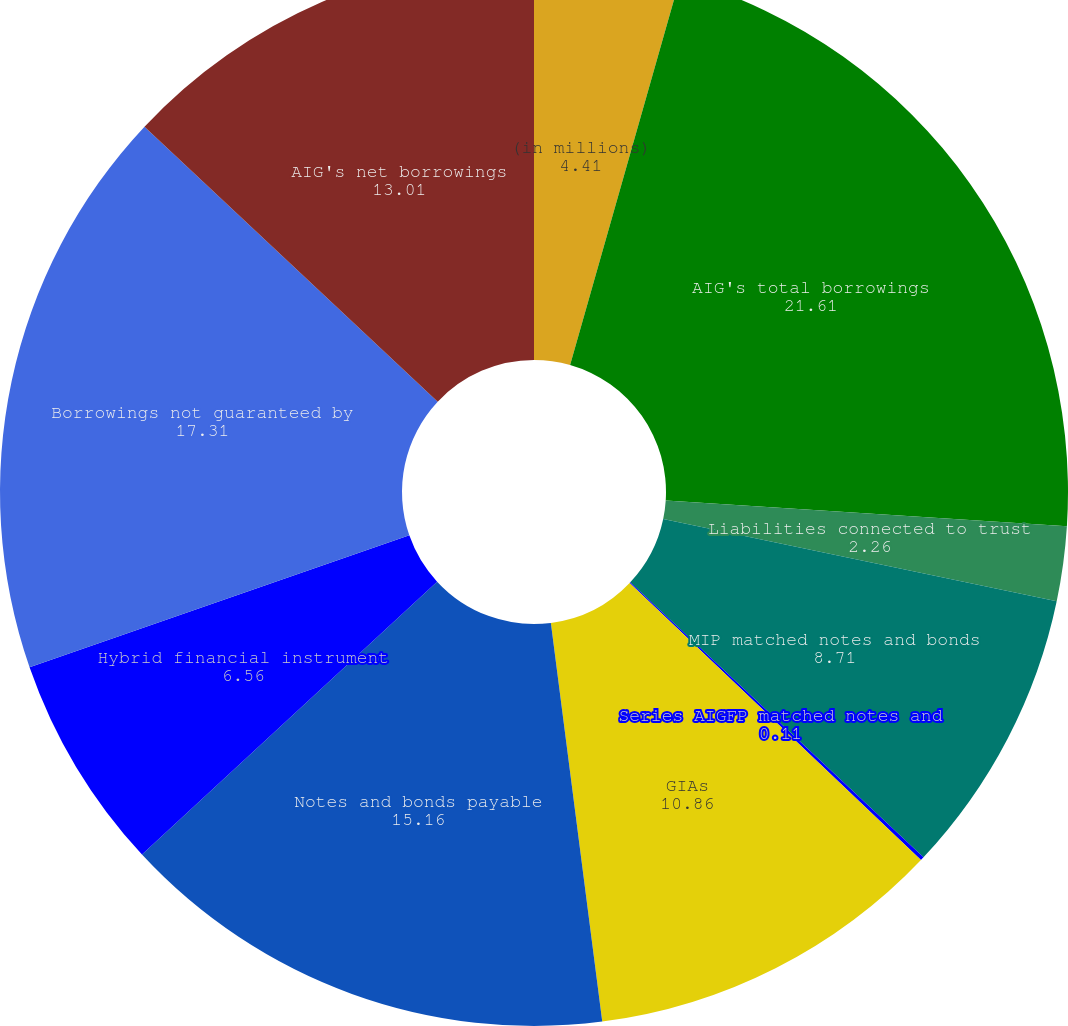Convert chart. <chart><loc_0><loc_0><loc_500><loc_500><pie_chart><fcel>(in millions)<fcel>AIG's total borrowings<fcel>Liabilities connected to trust<fcel>MIP matched notes and bonds<fcel>Series AIGFP matched notes and<fcel>GIAs<fcel>Notes and bonds payable<fcel>Hybrid financial instrument<fcel>Borrowings not guaranteed by<fcel>AIG's net borrowings<nl><fcel>4.41%<fcel>21.61%<fcel>2.26%<fcel>8.71%<fcel>0.11%<fcel>10.86%<fcel>15.16%<fcel>6.56%<fcel>17.31%<fcel>13.01%<nl></chart> 